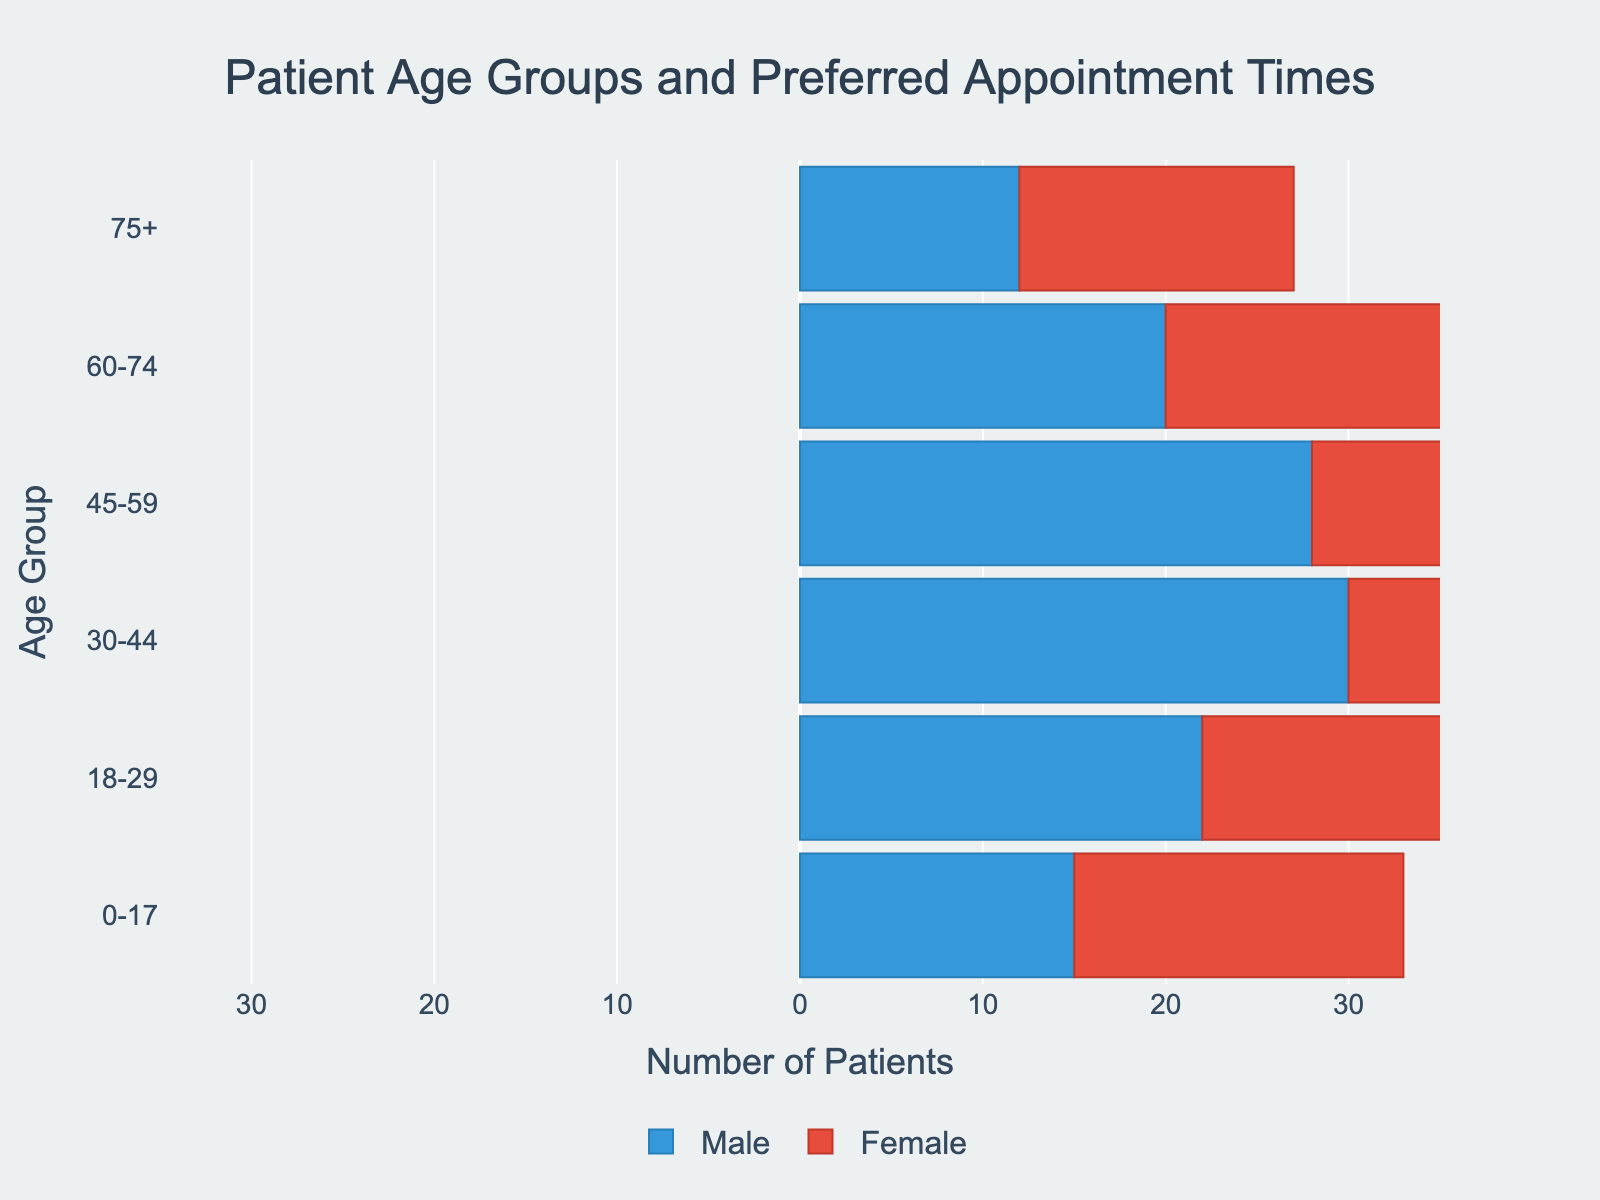What is the title of the figure? The title of the figure is prominently displayed at the top and is "Patient Age Groups and Preferred Appointment Times".
Answer: Patient Age Groups and Preferred Appointment Times Which age group has the highest number of female patients? By observing the bars colored in red, the age group 30-44 has the longest bar, indicating the highest number of female patients.
Answer: 30-44 How many male patients are there in the 18-29 age group? Looking at the blue bar for the 18-29 age group on the left side, the negative value representing male patients is -22. The absolute value gives the number of male patients.
Answer: 22 What is the total number of patients in the 0-17 age group? Adding the absolute values of male (-15) and female (18) patients gives the total number of patients: 15 + 18 = 33.
Answer: 33 Are there more male or female patients in the 45-59 age group? The blue bar (male) has a value of -28, and the red bar (female) has a value of 30. Comparing absolute values, the females have a higher count.
Answer: Female Which age group has the smallest difference in the number of male and female patients? Calculate the absolute difference for each age group and compare:
(0-17: 3, 18-29: 3, 30-44: 2, 45-59: 2, 60-74: 2, 75+: 3). The smallest difference is seen in age groups 30-44, 45-59, and 60-74.
Answer: 30-44, 45-59, 60-74 In which age group do males outnumber females? Looking at the blue (male) and red (female) bars, none of the age groups have longer blue bars compared to red bars, so there are no such age groups.
Answer: None What is the sum of female patients in the 18-29 and 30-44 age groups? Adding the number of female patients in the 18-29 (25) and 30-44 (32) age groups: 25 + 32 = 57.
Answer: 57 How many more female patients are there than male patients in the 60-74 age group? Female patients are 22 and male patients are -20. Absolute difference is 22 - 20 = 2.
Answer: 2 Do any age groups have a balanced number of male and female patients? Check for any age groups where the absolute values of the male and female bars are equal. None of the age groups have bars of equal length.
Answer: No 